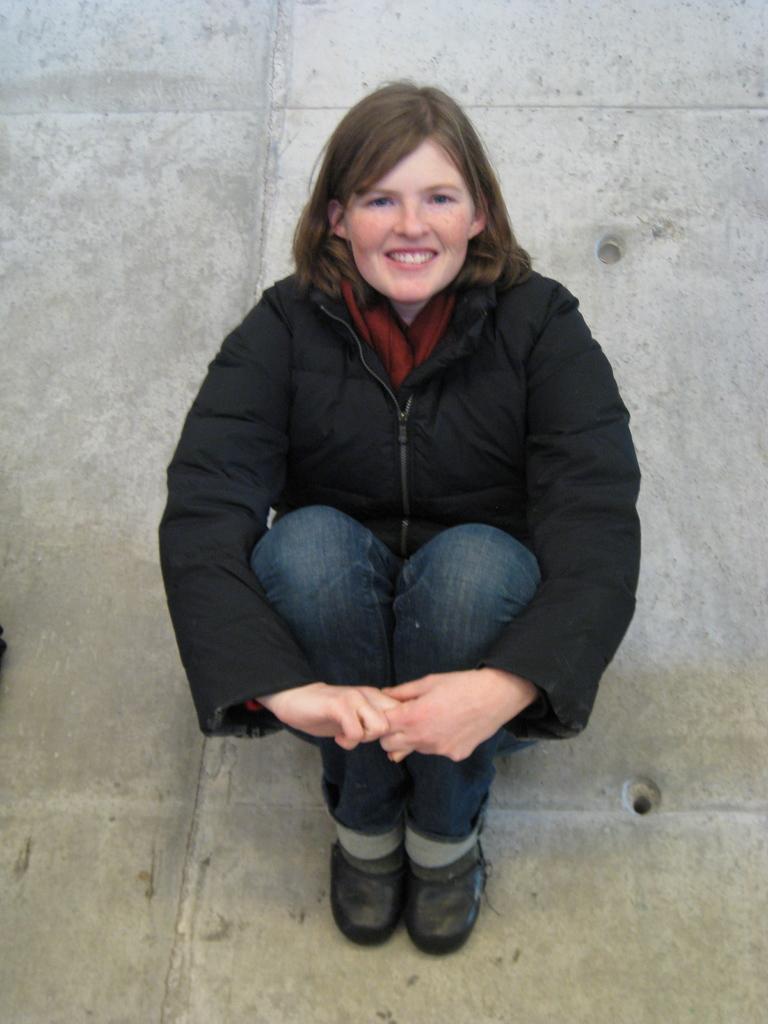Please provide a concise description of this image. In this picture we can see a woman sitting here, she wore a coat, jeans and shoes. 